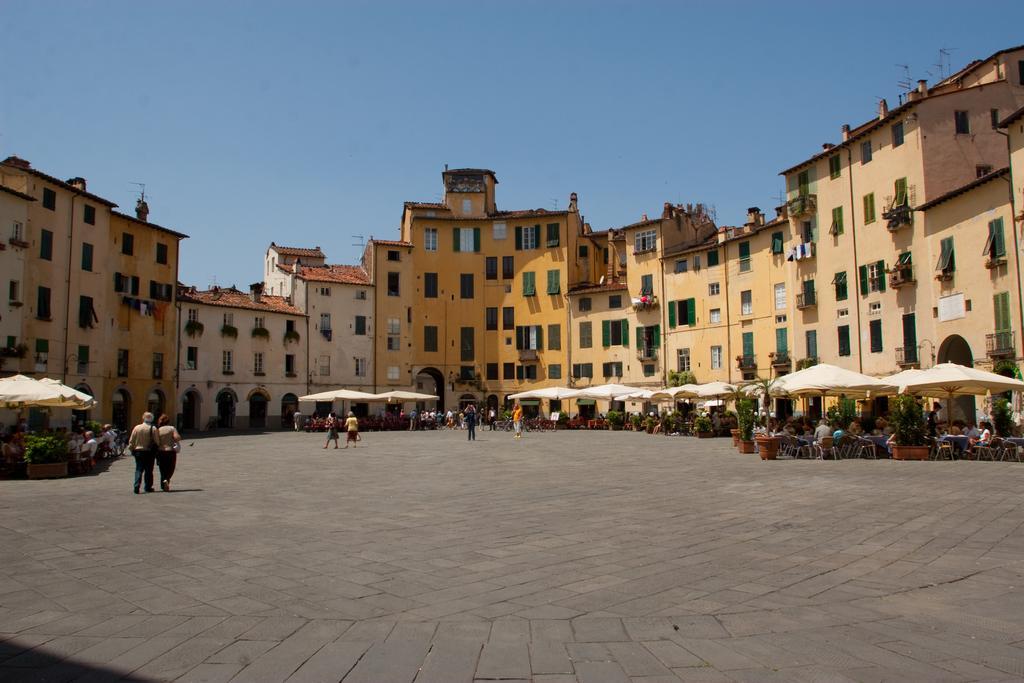Could you give a brief overview of what you see in this image? In this picture I can see group of people standing, there are group of people sitting on the chairs, there are plants, trees, umbrellas, houses, antennas, and in the background there is sky. 